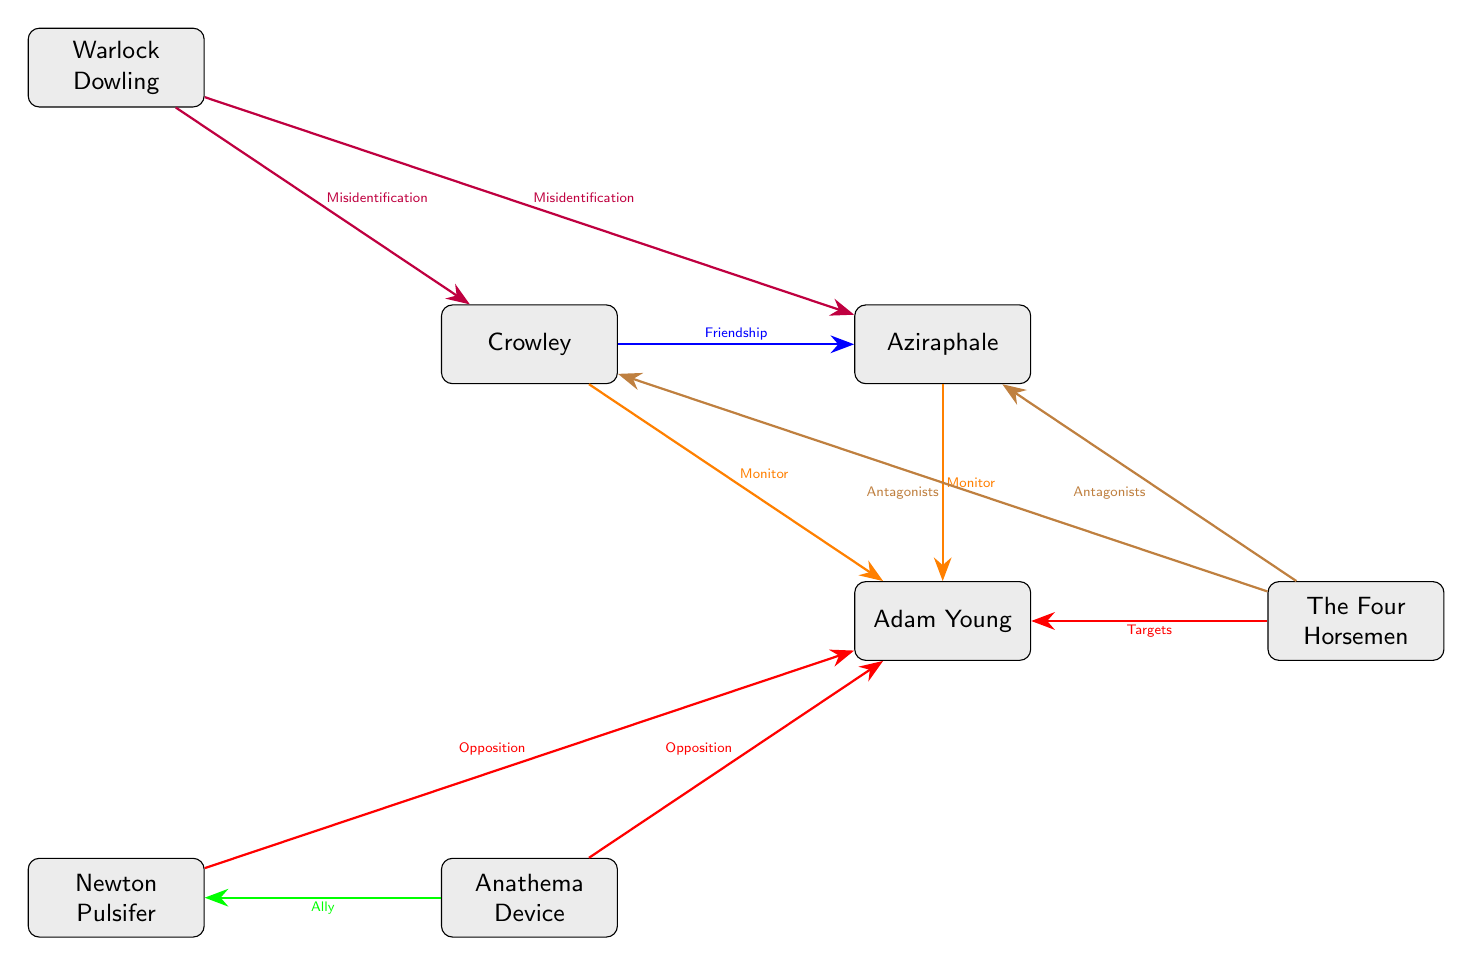What is the relationship between Crowley and Aziraphale? The diagram shows an arrow labeled "Friendship" connecting Crowley to Aziraphale. This indicates that their relationship is one of friendship.
Answer: Friendship How many characters are connected to Adam Young? The diagram shows three connections going outward from Adam Young: one to Crowley, one to Aziraphale, and one to Anathema Device. This totals three characters connected to him.
Answer: 3 Who opposes Adam Young? The diagram indicates two connections labeled "Opposition" coming from Anathema Device and Newton Pulsifer directed toward Adam Young, which identifies both characters as his opposers.
Answer: Anathema Device, Newton Pulsifer What type of connection exists between Anathema Device and Newton Pulsifer? The diagram has an arrow labeled "Ally" connecting Anathema Device to Newton Pulsifer. This specifies the type of relationship between them as being allied.
Answer: Ally Which character is misidentified by Warlock Dowling? The diagram shows two connections labeled "Misidentification" from Warlock Dowling to both Crowley and Aziraphale, meaning that he misidentifies both characters.
Answer: Crowley, Aziraphale How many total nodes are present in the diagram? By counting each character node represented in the diagram, we find seven nodes: Crowley, Aziraphale, Adam Young, Anathema Device, Newton Pulsifer, Warlock Dowling, and The Four Horsemen. This equals seven total nodes.
Answer: 7 What is the relationship type between The Four Horsemen and Adam Young? There is an arrow from The Four Horsemen to Adam Young labeled "Targets," which shows that they have a targeting relationship with him.
Answer: Targets Do both Crowley and Aziraphale face antagonism from The Four Horsemen? The diagram displays two arrows marked "Antagonists" from The Four Horsemen leading to both Crowley and Aziraphale, confirming that they indeed both face antagonism from The Four Horsemen.
Answer: Yes 